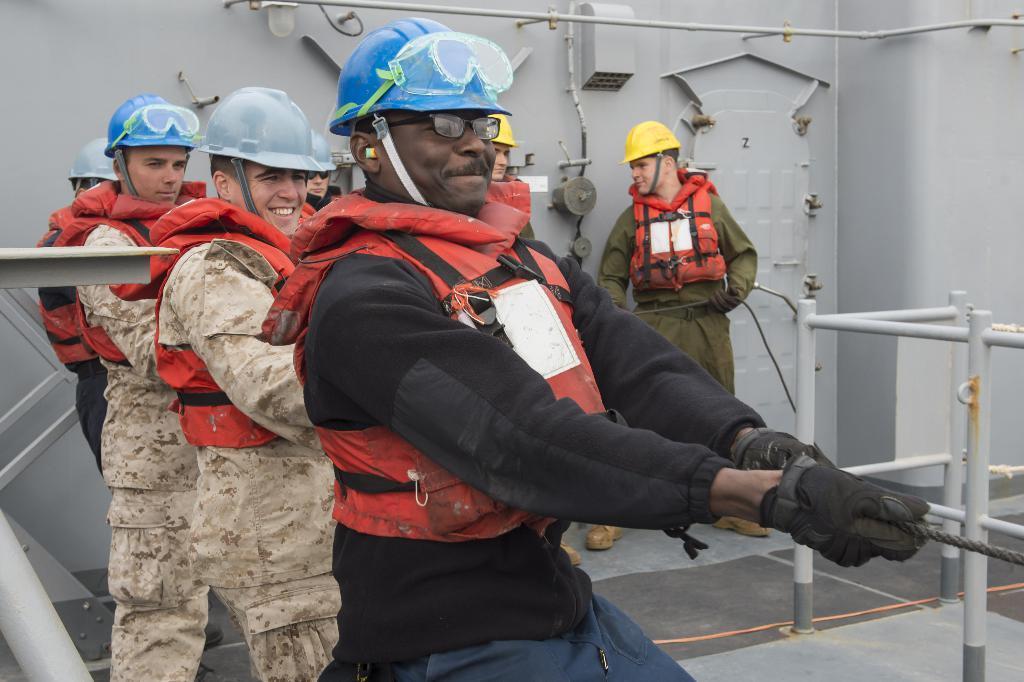Describe this image in one or two sentences. In this image we can see few persons and the persons are wearing helmets. In the foreground we can see a person pulling a rope. Behind the persons we can see a metal wall. On both sides we can see the metal objects. 